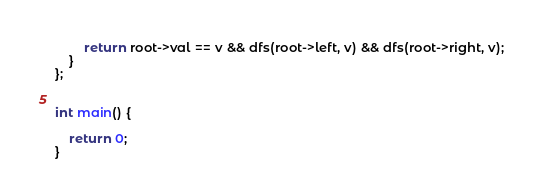Convert code to text. <code><loc_0><loc_0><loc_500><loc_500><_C++_>        return root->val == v && dfs(root->left, v) && dfs(root->right, v);
    }
};


int main() {

    return 0;
}</code> 